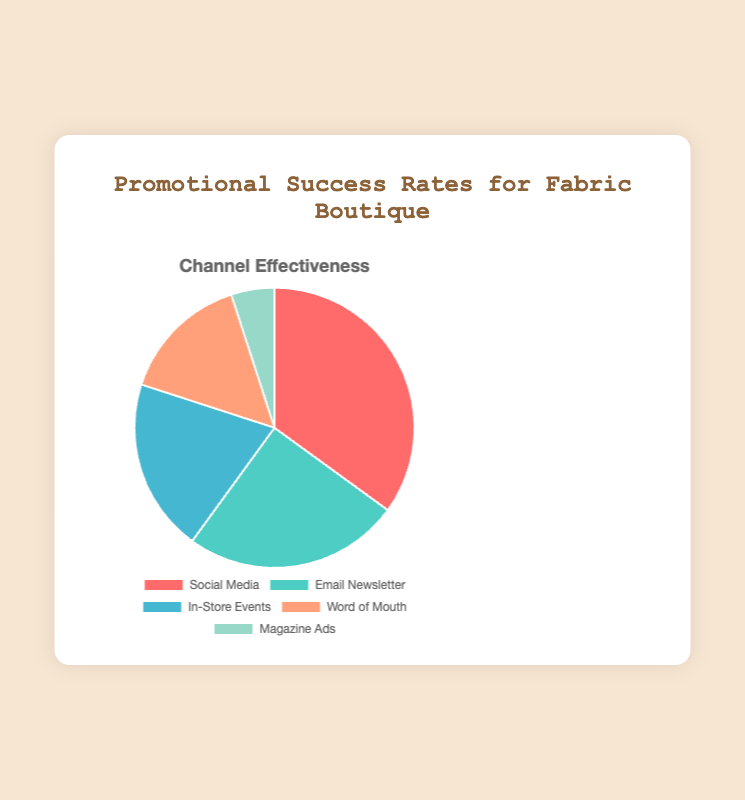Which promotional channel has the highest success rate? From the chart, we see that Social Media has the largest section of the pie, indicating the highest success rate.
Answer: Social Media How does the success rate of Email Newsletter compare to Magazine Ads? By observing the pie chart, the Email Newsletter section is much larger than the Magazine Ads section. The success rate for Email Newsletter is 25%, while for Magazine Ads, it's just 5%.
Answer: Email Newsletter is higher What is the combined success rate of In-Store Events and Word of Mouth? The success rate for In-Store Events is 20% and for Word of Mouth, it is 15%. Adding these together gives 20% + 15% = 35%.
Answer: 35% Which promotional channel has the smallest success rate? The smallest section of the pie chart corresponds to Magazine Ads, indicating the lowest success rate of 5%.
Answer: Magazine Ads What is the difference in success rates between Social Media and In-Store Events? Social Media has a success rate of 35%, and In-Store Events have a success rate of 20%. The difference is calculated as 35% - 20% = 15%.
Answer: 15% What proportion of the total success rate is represented by Word of Mouth? Word of Mouth has a success rate of 15%. Since this is out of a total of 100%, the proportion is 15/100, which is 15%.
Answer: 15% How does the success rate of Social Media compare to the total success rate of all non-digital channels (In-Store Events, Word of Mouth, Magazine Ads)? Adding up the success rates of non-digital channels: In-Store Events (20%), Word of Mouth (15%), Magazine Ads (5%) gives a total of 40%. Compare this to Social Media’s 35%, Social Media is slightly lower.
Answer: Social Media is slightly lower If we grouped digital channels together (Social Media, Email Newsletter), what is their combined success rate? Social Media is 35% and Email Newsletter is 25%. Their combined success rate is 35% + 25% = 60%.
Answer: 60% 